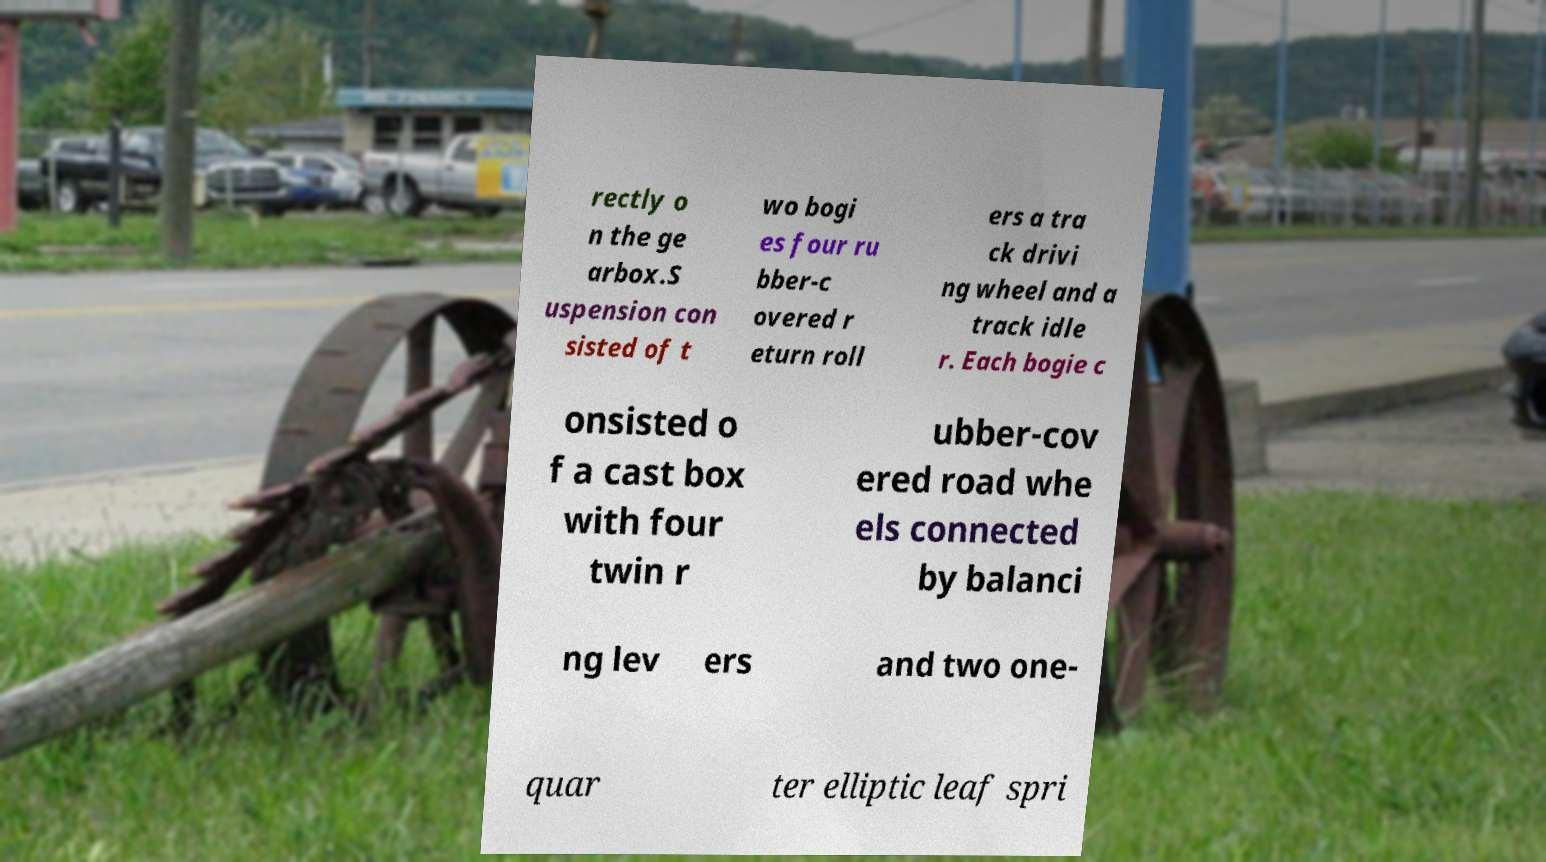For documentation purposes, I need the text within this image transcribed. Could you provide that? rectly o n the ge arbox.S uspension con sisted of t wo bogi es four ru bber-c overed r eturn roll ers a tra ck drivi ng wheel and a track idle r. Each bogie c onsisted o f a cast box with four twin r ubber-cov ered road whe els connected by balanci ng lev ers and two one- quar ter elliptic leaf spri 